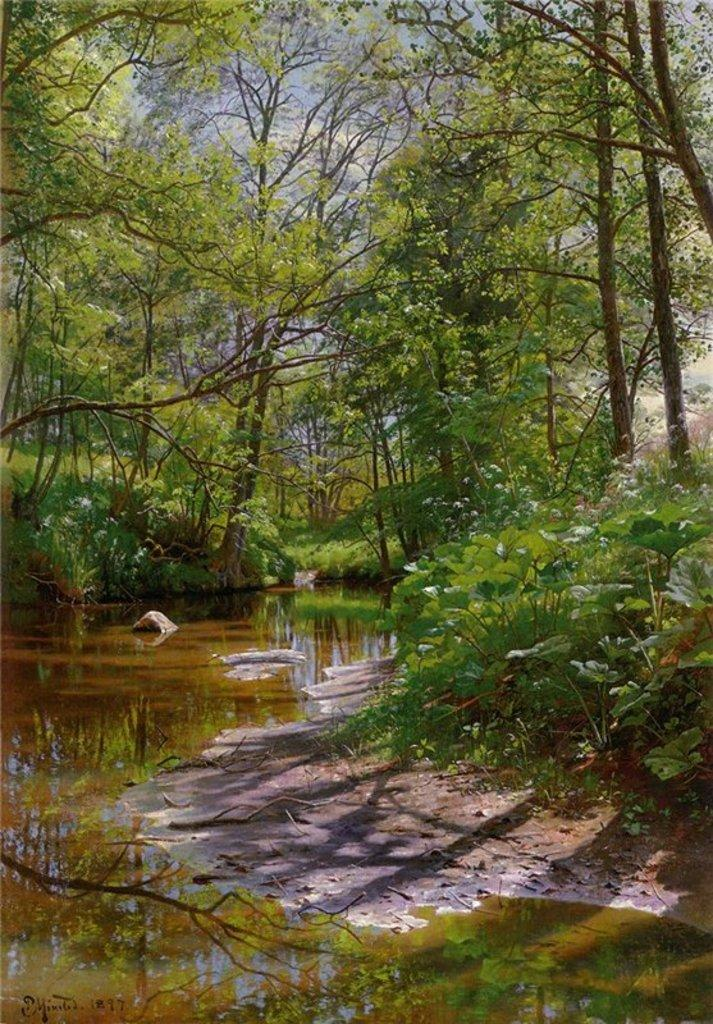What is visible in the image? Water is visible in the image. What can be seen in the background of the image? There are trees in the background of the image. What is the color of the trees? The trees are green in color. What colors are present in the sky? The sky is blue and white in color. How many actors are present in the image? There are no actors present in the image. What type of zephyr can be seen blowing through the trees in the image? There is no zephyr present in the image, as it is a meteorological term for a gentle breeze and not a visible object. 